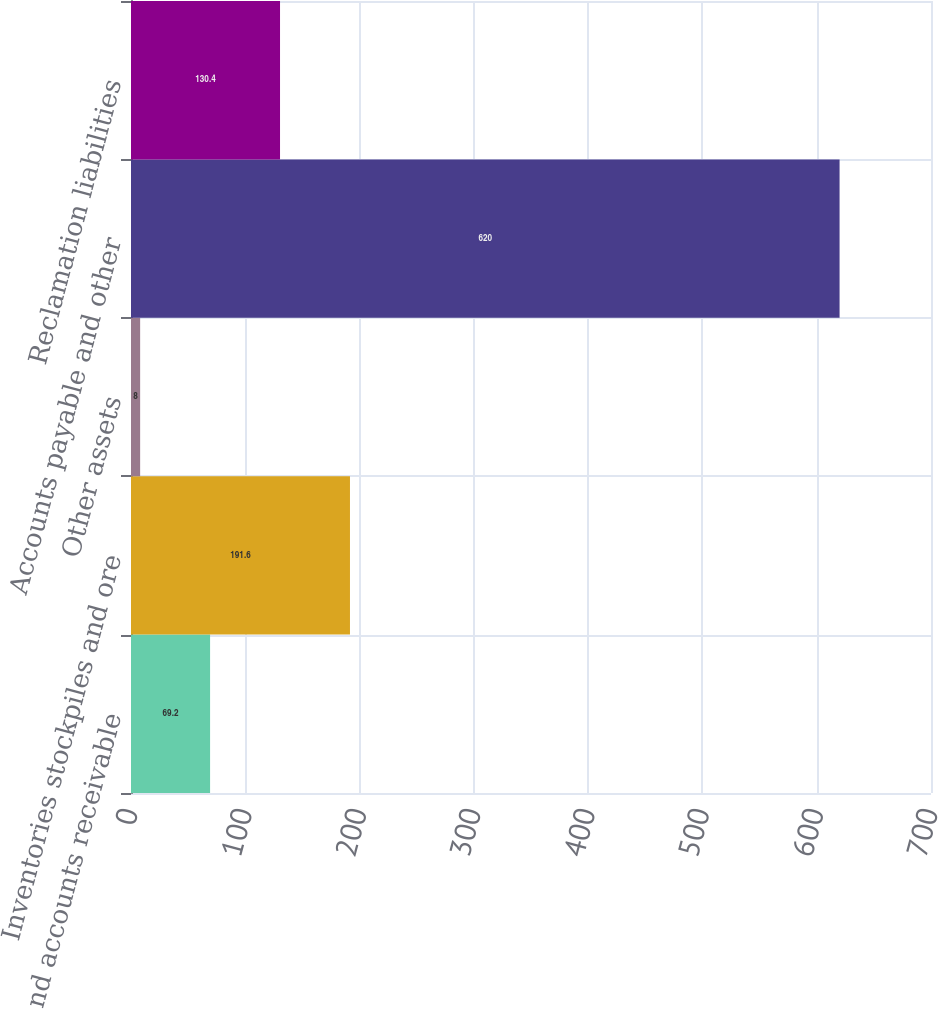Convert chart. <chart><loc_0><loc_0><loc_500><loc_500><bar_chart><fcel>Trade and accounts receivable<fcel>Inventories stockpiles and ore<fcel>Other assets<fcel>Accounts payable and other<fcel>Reclamation liabilities<nl><fcel>69.2<fcel>191.6<fcel>8<fcel>620<fcel>130.4<nl></chart> 